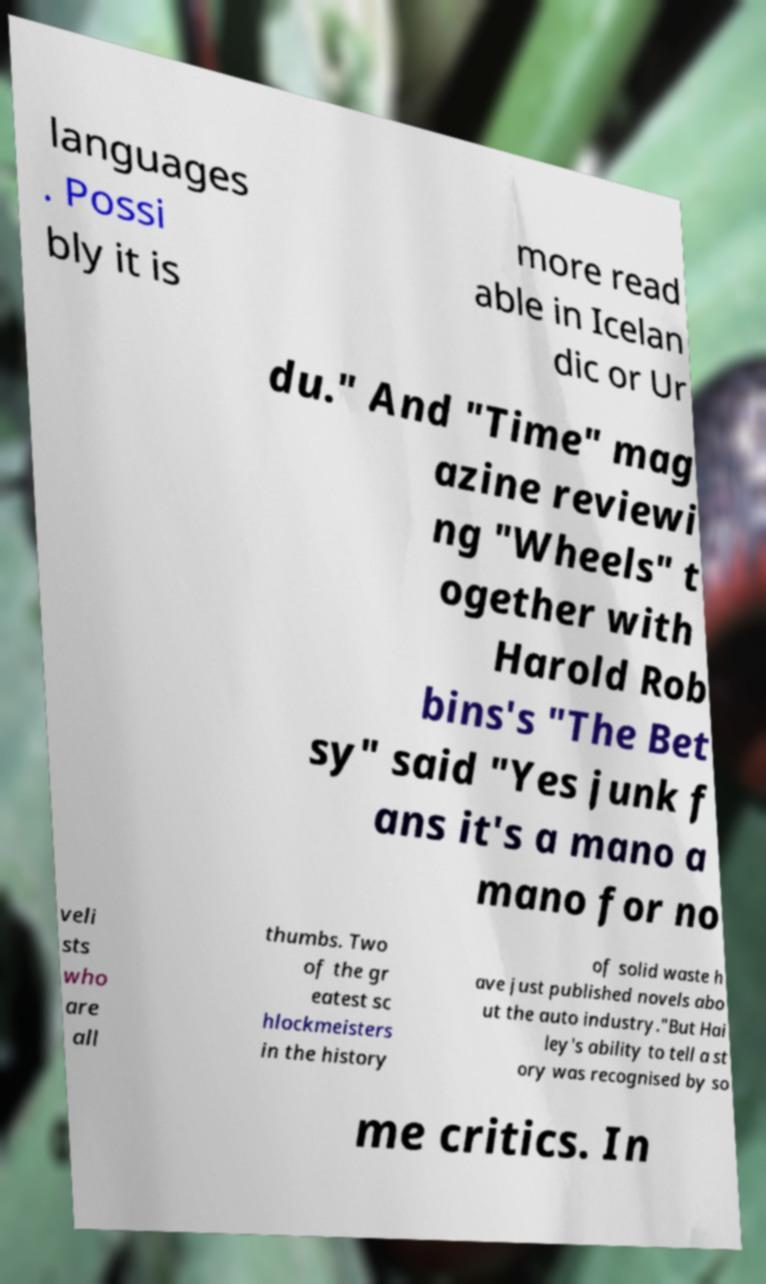I need the written content from this picture converted into text. Can you do that? languages . Possi bly it is more read able in Icelan dic or Ur du." And "Time" mag azine reviewi ng "Wheels" t ogether with Harold Rob bins's "The Bet sy" said "Yes junk f ans it's a mano a mano for no veli sts who are all thumbs. Two of the gr eatest sc hlockmeisters in the history of solid waste h ave just published novels abo ut the auto industry."But Hai ley's ability to tell a st ory was recognised by so me critics. In 